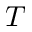<formula> <loc_0><loc_0><loc_500><loc_500>T</formula> 